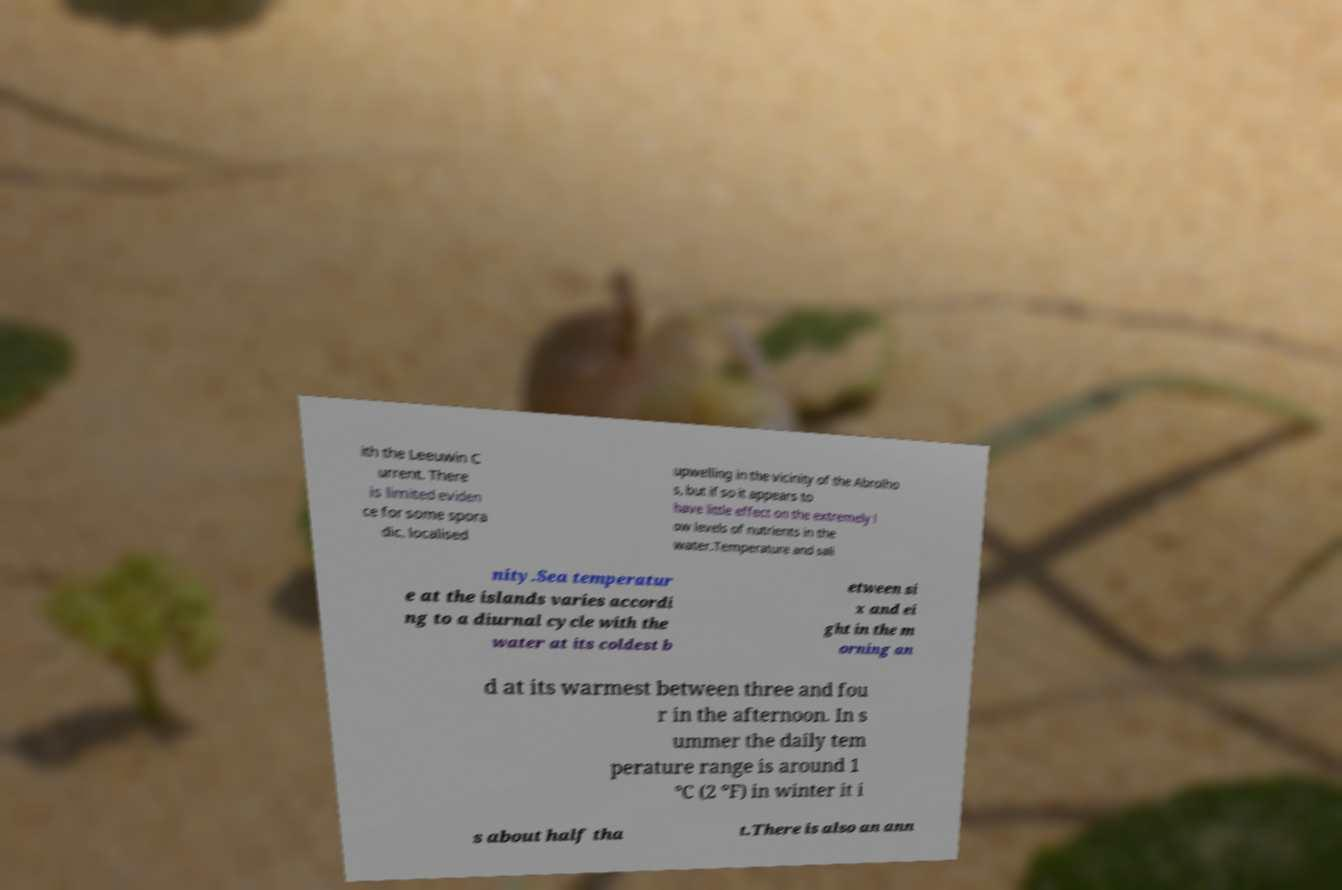Could you extract and type out the text from this image? ith the Leeuwin C urrent. There is limited eviden ce for some spora dic, localised upwelling in the vicinity of the Abrolho s, but if so it appears to have little effect on the extremely l ow levels of nutrients in the water.Temperature and sali nity.Sea temperatur e at the islands varies accordi ng to a diurnal cycle with the water at its coldest b etween si x and ei ght in the m orning an d at its warmest between three and fou r in the afternoon. In s ummer the daily tem perature range is around 1 °C (2 °F) in winter it i s about half tha t.There is also an ann 